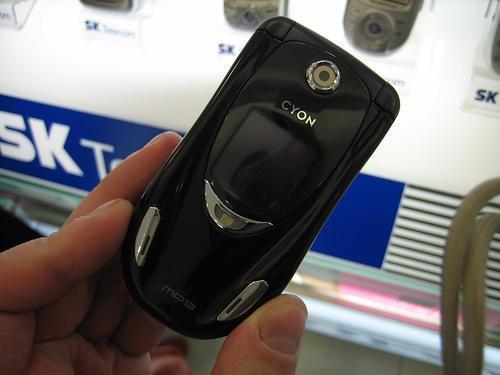How many people are in the picture?
Give a very brief answer. 2. How many kites do you see?
Give a very brief answer. 0. 